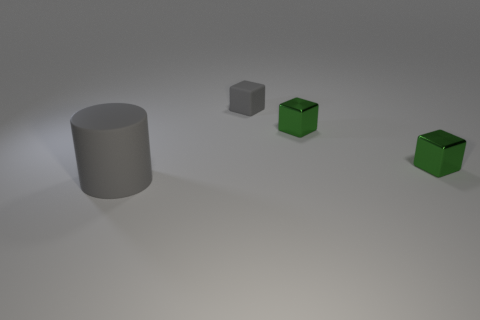What is the color of the large matte thing that is to the left of the small gray matte cube?
Your answer should be very brief. Gray. Is there a metal object that is behind the rubber thing that is in front of the gray rubber block?
Make the answer very short. Yes. How many objects are either gray matte cylinders that are in front of the matte block or small blue shiny spheres?
Ensure brevity in your answer.  1. Is there anything else that has the same size as the rubber cylinder?
Make the answer very short. No. What material is the gray thing in front of the gray rubber object that is on the right side of the cylinder made of?
Your answer should be very brief. Rubber. Are there an equal number of tiny matte objects on the left side of the gray matte cylinder and large gray cylinders that are right of the small rubber object?
Offer a terse response. Yes. What number of things are gray matte things that are on the right side of the big matte cylinder or tiny blocks on the right side of the small rubber cube?
Provide a short and direct response. 3. What is the size of the rubber thing on the right side of the object that is on the left side of the gray matte thing that is on the right side of the cylinder?
Your answer should be very brief. Small. Is the number of gray rubber cylinders greater than the number of blue matte things?
Provide a succinct answer. Yes. Is the material of the thing on the left side of the small gray rubber block the same as the small gray thing?
Offer a terse response. Yes. 